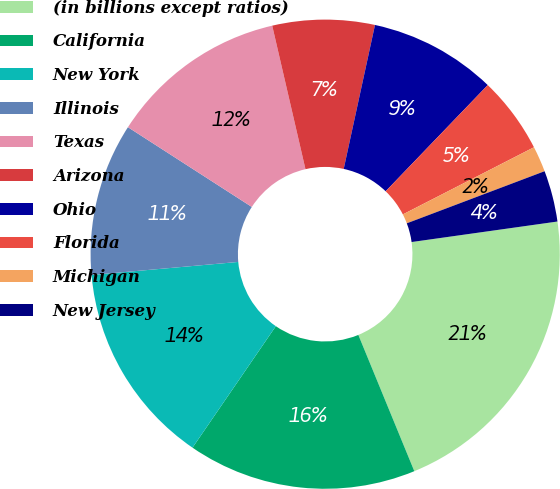Convert chart to OTSL. <chart><loc_0><loc_0><loc_500><loc_500><pie_chart><fcel>(in billions except ratios)<fcel>California<fcel>New York<fcel>Illinois<fcel>Texas<fcel>Arizona<fcel>Ohio<fcel>Florida<fcel>Michigan<fcel>New Jersey<nl><fcel>21.02%<fcel>15.77%<fcel>14.02%<fcel>10.52%<fcel>12.27%<fcel>7.03%<fcel>8.78%<fcel>5.28%<fcel>1.78%<fcel>3.53%<nl></chart> 